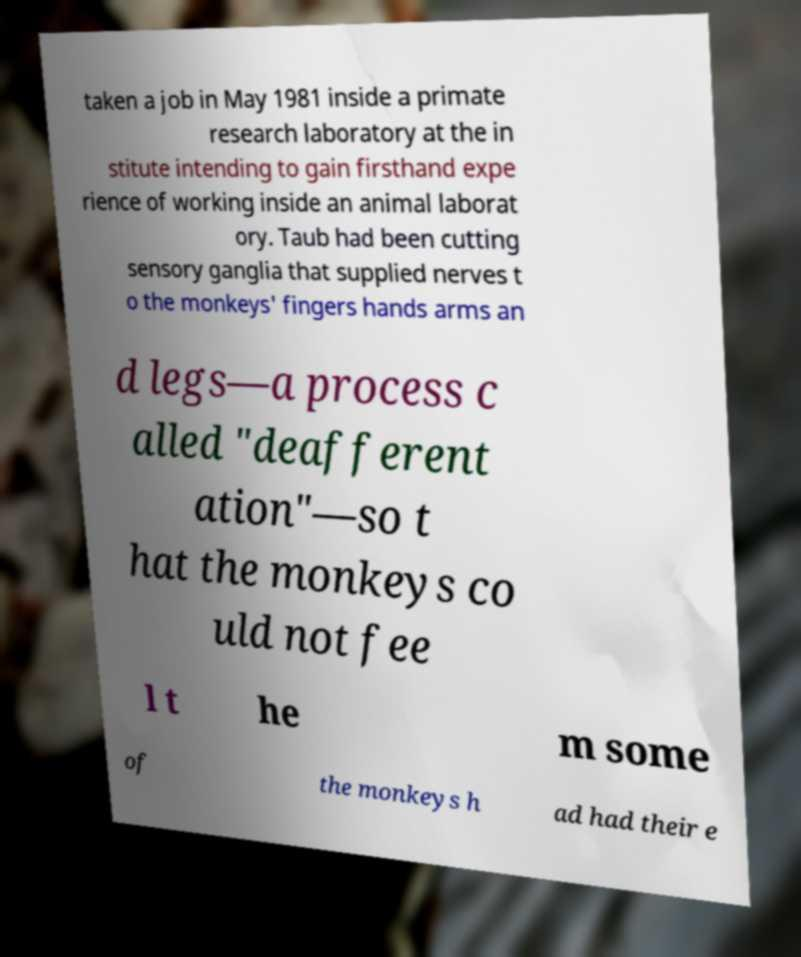Could you assist in decoding the text presented in this image and type it out clearly? taken a job in May 1981 inside a primate research laboratory at the in stitute intending to gain firsthand expe rience of working inside an animal laborat ory. Taub had been cutting sensory ganglia that supplied nerves t o the monkeys' fingers hands arms an d legs—a process c alled "deafferent ation"—so t hat the monkeys co uld not fee l t he m some of the monkeys h ad had their e 